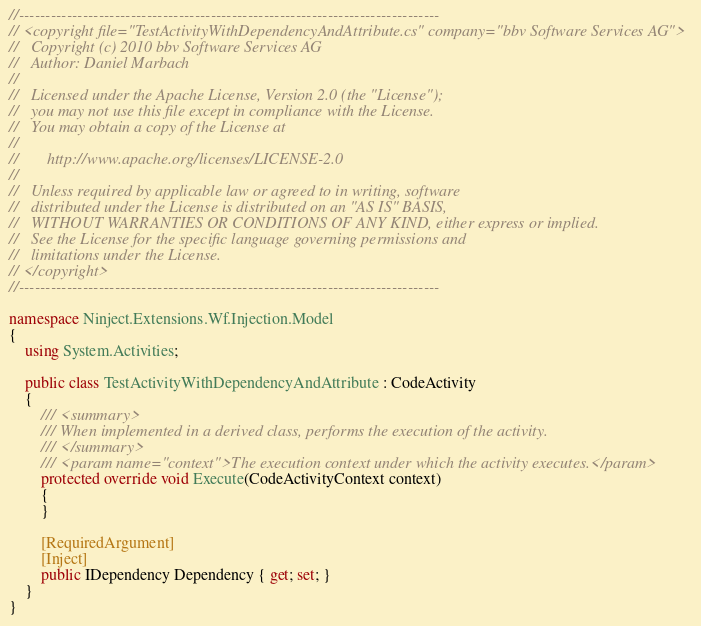<code> <loc_0><loc_0><loc_500><loc_500><_C#_>//-------------------------------------------------------------------------------
// <copyright file="TestActivityWithDependencyAndAttribute.cs" company="bbv Software Services AG">
//   Copyright (c) 2010 bbv Software Services AG
//   Author: Daniel Marbach
//
//   Licensed under the Apache License, Version 2.0 (the "License");
//   you may not use this file except in compliance with the License.
//   You may obtain a copy of the License at
//
//       http://www.apache.org/licenses/LICENSE-2.0
//
//   Unless required by applicable law or agreed to in writing, software
//   distributed under the License is distributed on an "AS IS" BASIS,
//   WITHOUT WARRANTIES OR CONDITIONS OF ANY KIND, either express or implied.
//   See the License for the specific language governing permissions and
//   limitations under the License.
// </copyright>
//-------------------------------------------------------------------------------

namespace Ninject.Extensions.Wf.Injection.Model
{
    using System.Activities;

    public class TestActivityWithDependencyAndAttribute : CodeActivity
    {
        /// <summary>
        /// When implemented in a derived class, performs the execution of the activity.
        /// </summary>
        /// <param name="context">The execution context under which the activity executes.</param>
        protected override void Execute(CodeActivityContext context)
        {
        }

        [RequiredArgument]
        [Inject]
        public IDependency Dependency { get; set; }
    }
}</code> 